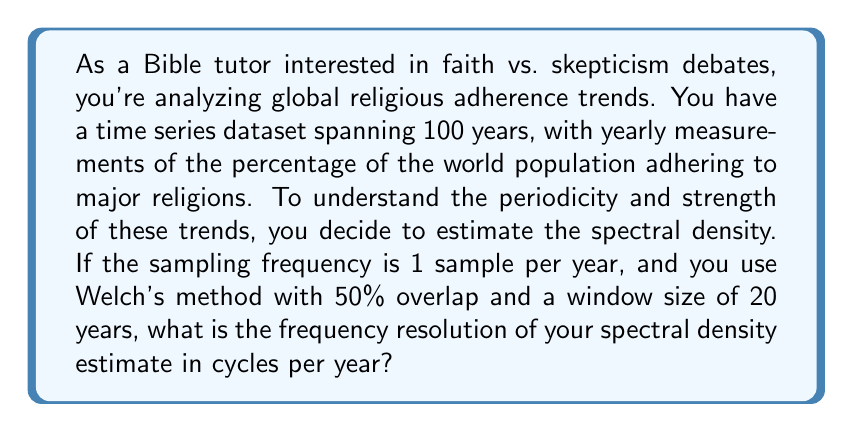Solve this math problem. Let's approach this step-by-step:

1) In spectral analysis, the frequency resolution $\Delta f$ is given by:

   $$\Delta f = \frac{1}{N T_s}$$

   where $N$ is the number of samples in each segment and $T_s$ is the sampling period.

2) In this case, we're using Welch's method with a window size of 20 years. This means $N = 20$.

3) The sampling period $T_s$ is 1 year, as we have yearly measurements.

4) Substituting these values into our equation:

   $$\Delta f = \frac{1}{20 \cdot 1} = \frac{1}{20} \text{ cycles/year}$$

5) To interpret this: we can distinguish between frequency components that are at least $\frac{1}{20}$ cycles/year apart.

6) Note that the 50% overlap doesn't affect the frequency resolution, but it does improve the statistical stability of the estimate.

This frequency resolution allows us to detect cycles in religious adherence trends that occur over periods of 20 years or longer, which could be relevant for generational shifts or long-term societal changes.
Answer: $\frac{1}{20}$ cycles/year 